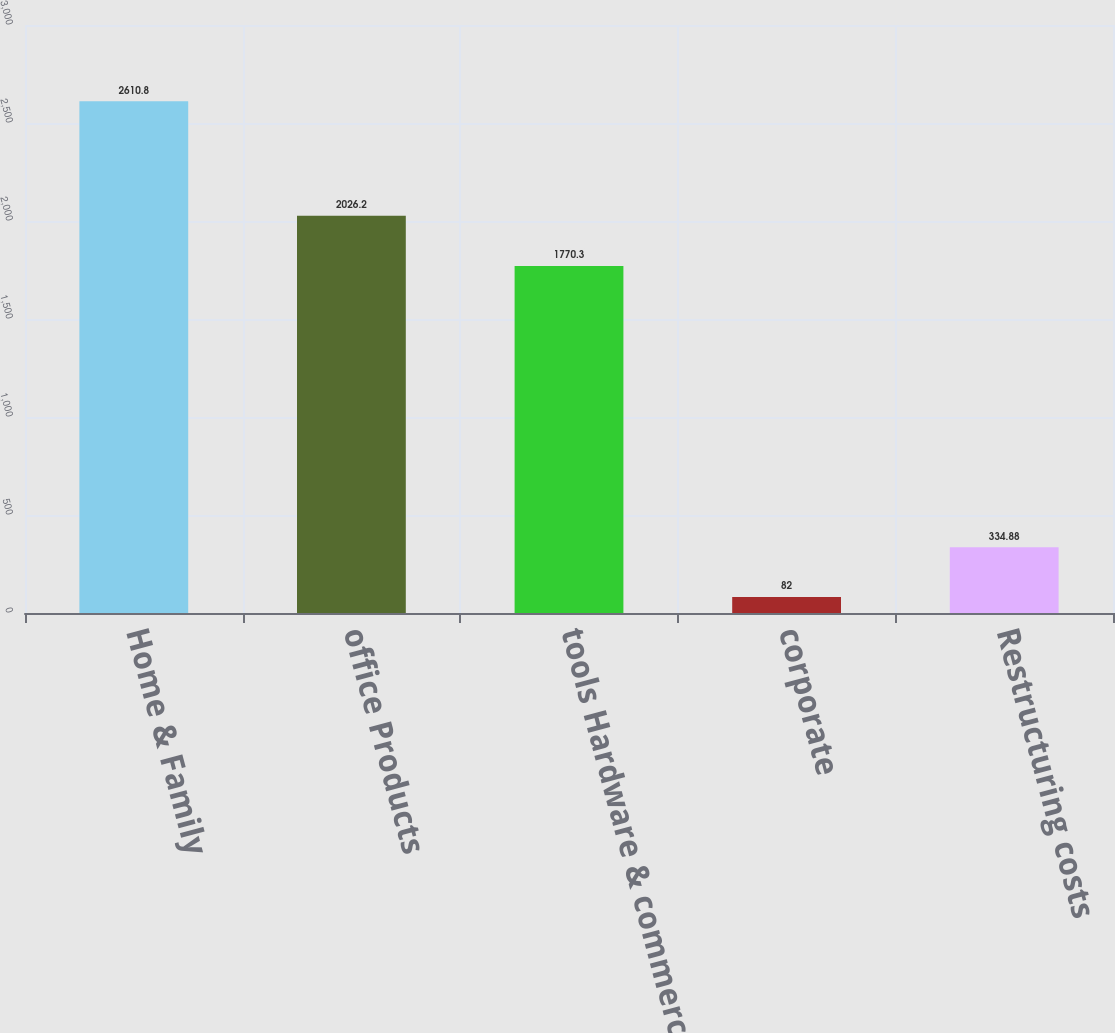<chart> <loc_0><loc_0><loc_500><loc_500><bar_chart><fcel>Home & Family<fcel>office Products<fcel>tools Hardware & commercial<fcel>corporate<fcel>Restructuring costs<nl><fcel>2610.8<fcel>2026.2<fcel>1770.3<fcel>82<fcel>334.88<nl></chart> 